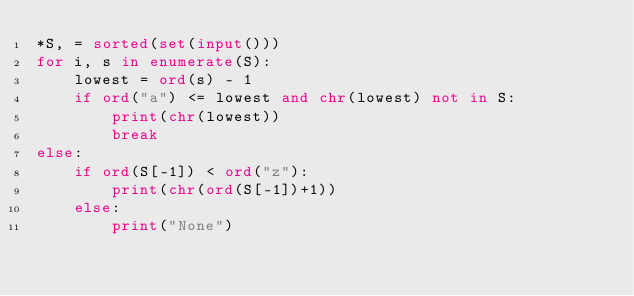Convert code to text. <code><loc_0><loc_0><loc_500><loc_500><_Python_>*S, = sorted(set(input()))
for i, s in enumerate(S):
	lowest = ord(s) - 1
	if ord("a") <= lowest and chr(lowest) not in S:
		print(chr(lowest))
		break
else:
	if ord(S[-1]) < ord("z"):
		print(chr(ord(S[-1])+1))
	else:
		print("None")
</code> 